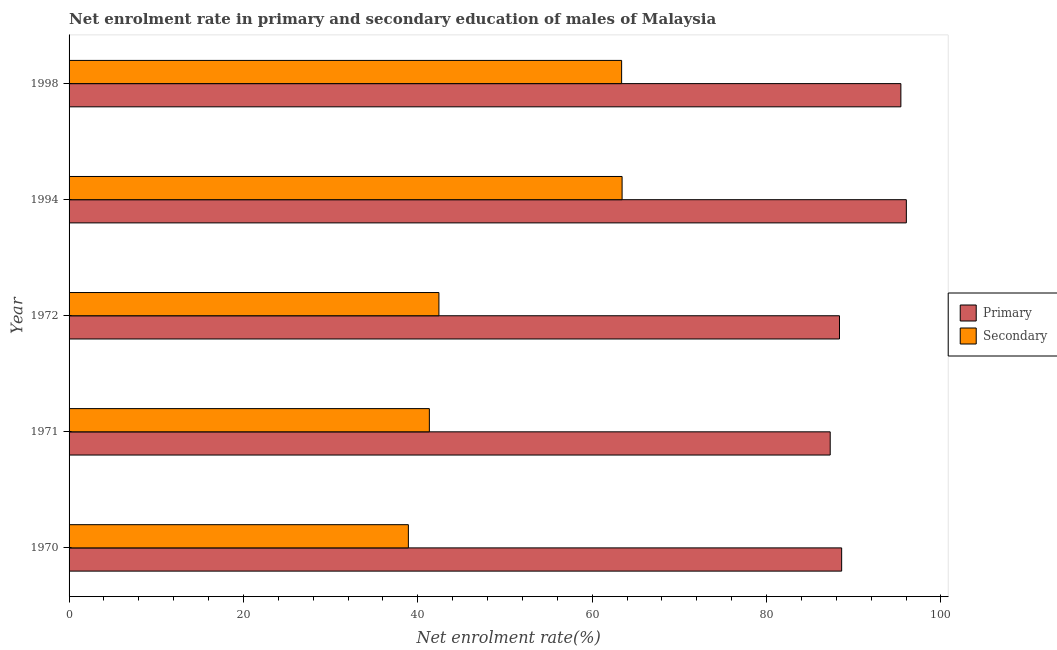Are the number of bars on each tick of the Y-axis equal?
Provide a short and direct response. Yes. What is the label of the 3rd group of bars from the top?
Provide a short and direct response. 1972. What is the enrollment rate in primary education in 1971?
Provide a succinct answer. 87.3. Across all years, what is the maximum enrollment rate in secondary education?
Offer a very short reply. 63.43. Across all years, what is the minimum enrollment rate in secondary education?
Give a very brief answer. 38.92. In which year was the enrollment rate in secondary education maximum?
Keep it short and to the point. 1994. In which year was the enrollment rate in secondary education minimum?
Offer a terse response. 1970. What is the total enrollment rate in secondary education in the graph?
Offer a terse response. 249.46. What is the difference between the enrollment rate in secondary education in 1970 and that in 1971?
Offer a very short reply. -2.41. What is the difference between the enrollment rate in primary education in 1998 and the enrollment rate in secondary education in 1972?
Your answer should be very brief. 52.98. What is the average enrollment rate in primary education per year?
Offer a terse response. 91.14. In the year 1998, what is the difference between the enrollment rate in primary education and enrollment rate in secondary education?
Keep it short and to the point. 32.03. In how many years, is the enrollment rate in primary education greater than 92 %?
Provide a short and direct response. 2. Is the difference between the enrollment rate in primary education in 1972 and 1994 greater than the difference between the enrollment rate in secondary education in 1972 and 1994?
Offer a terse response. Yes. What is the difference between the highest and the second highest enrollment rate in secondary education?
Ensure brevity in your answer.  0.05. What is the difference between the highest and the lowest enrollment rate in secondary education?
Ensure brevity in your answer.  24.51. In how many years, is the enrollment rate in secondary education greater than the average enrollment rate in secondary education taken over all years?
Keep it short and to the point. 2. What does the 2nd bar from the top in 1972 represents?
Offer a terse response. Primary. What does the 1st bar from the bottom in 1994 represents?
Offer a very short reply. Primary. Are all the bars in the graph horizontal?
Offer a terse response. Yes. How many years are there in the graph?
Offer a terse response. 5. Are the values on the major ticks of X-axis written in scientific E-notation?
Offer a very short reply. No. Does the graph contain any zero values?
Offer a very short reply. No. How many legend labels are there?
Make the answer very short. 2. How are the legend labels stacked?
Ensure brevity in your answer.  Vertical. What is the title of the graph?
Offer a very short reply. Net enrolment rate in primary and secondary education of males of Malaysia. What is the label or title of the X-axis?
Provide a succinct answer. Net enrolment rate(%). What is the label or title of the Y-axis?
Provide a short and direct response. Year. What is the Net enrolment rate(%) in Primary in 1970?
Keep it short and to the point. 88.61. What is the Net enrolment rate(%) in Secondary in 1970?
Offer a terse response. 38.92. What is the Net enrolment rate(%) in Primary in 1971?
Offer a terse response. 87.3. What is the Net enrolment rate(%) of Secondary in 1971?
Ensure brevity in your answer.  41.32. What is the Net enrolment rate(%) in Primary in 1972?
Keep it short and to the point. 88.36. What is the Net enrolment rate(%) in Secondary in 1972?
Ensure brevity in your answer.  42.42. What is the Net enrolment rate(%) in Primary in 1994?
Provide a short and direct response. 96.03. What is the Net enrolment rate(%) in Secondary in 1994?
Offer a very short reply. 63.43. What is the Net enrolment rate(%) of Primary in 1998?
Make the answer very short. 95.4. What is the Net enrolment rate(%) of Secondary in 1998?
Your response must be concise. 63.38. Across all years, what is the maximum Net enrolment rate(%) of Primary?
Offer a terse response. 96.03. Across all years, what is the maximum Net enrolment rate(%) in Secondary?
Keep it short and to the point. 63.43. Across all years, what is the minimum Net enrolment rate(%) in Primary?
Offer a very short reply. 87.3. Across all years, what is the minimum Net enrolment rate(%) of Secondary?
Make the answer very short. 38.92. What is the total Net enrolment rate(%) of Primary in the graph?
Keep it short and to the point. 455.71. What is the total Net enrolment rate(%) of Secondary in the graph?
Your response must be concise. 249.46. What is the difference between the Net enrolment rate(%) of Primary in 1970 and that in 1971?
Give a very brief answer. 1.31. What is the difference between the Net enrolment rate(%) in Secondary in 1970 and that in 1971?
Offer a terse response. -2.41. What is the difference between the Net enrolment rate(%) of Primary in 1970 and that in 1972?
Offer a very short reply. 0.25. What is the difference between the Net enrolment rate(%) of Secondary in 1970 and that in 1972?
Your answer should be compact. -3.5. What is the difference between the Net enrolment rate(%) in Primary in 1970 and that in 1994?
Offer a very short reply. -7.42. What is the difference between the Net enrolment rate(%) in Secondary in 1970 and that in 1994?
Provide a succinct answer. -24.51. What is the difference between the Net enrolment rate(%) in Primary in 1970 and that in 1998?
Ensure brevity in your answer.  -6.79. What is the difference between the Net enrolment rate(%) of Secondary in 1970 and that in 1998?
Your answer should be compact. -24.46. What is the difference between the Net enrolment rate(%) of Primary in 1971 and that in 1972?
Ensure brevity in your answer.  -1.06. What is the difference between the Net enrolment rate(%) of Secondary in 1971 and that in 1972?
Keep it short and to the point. -1.1. What is the difference between the Net enrolment rate(%) in Primary in 1971 and that in 1994?
Your answer should be compact. -8.73. What is the difference between the Net enrolment rate(%) of Secondary in 1971 and that in 1994?
Give a very brief answer. -22.11. What is the difference between the Net enrolment rate(%) in Primary in 1971 and that in 1998?
Ensure brevity in your answer.  -8.1. What is the difference between the Net enrolment rate(%) in Secondary in 1971 and that in 1998?
Give a very brief answer. -22.05. What is the difference between the Net enrolment rate(%) of Primary in 1972 and that in 1994?
Offer a very short reply. -7.67. What is the difference between the Net enrolment rate(%) of Secondary in 1972 and that in 1994?
Keep it short and to the point. -21.01. What is the difference between the Net enrolment rate(%) of Primary in 1972 and that in 1998?
Offer a very short reply. -7.04. What is the difference between the Net enrolment rate(%) in Secondary in 1972 and that in 1998?
Your answer should be very brief. -20.96. What is the difference between the Net enrolment rate(%) of Primary in 1994 and that in 1998?
Offer a terse response. 0.63. What is the difference between the Net enrolment rate(%) in Secondary in 1994 and that in 1998?
Keep it short and to the point. 0.05. What is the difference between the Net enrolment rate(%) of Primary in 1970 and the Net enrolment rate(%) of Secondary in 1971?
Your answer should be very brief. 47.29. What is the difference between the Net enrolment rate(%) of Primary in 1970 and the Net enrolment rate(%) of Secondary in 1972?
Make the answer very short. 46.19. What is the difference between the Net enrolment rate(%) in Primary in 1970 and the Net enrolment rate(%) in Secondary in 1994?
Make the answer very short. 25.18. What is the difference between the Net enrolment rate(%) of Primary in 1970 and the Net enrolment rate(%) of Secondary in 1998?
Provide a succinct answer. 25.24. What is the difference between the Net enrolment rate(%) in Primary in 1971 and the Net enrolment rate(%) in Secondary in 1972?
Make the answer very short. 44.88. What is the difference between the Net enrolment rate(%) in Primary in 1971 and the Net enrolment rate(%) in Secondary in 1994?
Your response must be concise. 23.87. What is the difference between the Net enrolment rate(%) of Primary in 1971 and the Net enrolment rate(%) of Secondary in 1998?
Keep it short and to the point. 23.92. What is the difference between the Net enrolment rate(%) of Primary in 1972 and the Net enrolment rate(%) of Secondary in 1994?
Keep it short and to the point. 24.93. What is the difference between the Net enrolment rate(%) of Primary in 1972 and the Net enrolment rate(%) of Secondary in 1998?
Your answer should be compact. 24.99. What is the difference between the Net enrolment rate(%) of Primary in 1994 and the Net enrolment rate(%) of Secondary in 1998?
Your response must be concise. 32.66. What is the average Net enrolment rate(%) in Primary per year?
Ensure brevity in your answer.  91.14. What is the average Net enrolment rate(%) of Secondary per year?
Offer a very short reply. 49.89. In the year 1970, what is the difference between the Net enrolment rate(%) in Primary and Net enrolment rate(%) in Secondary?
Make the answer very short. 49.7. In the year 1971, what is the difference between the Net enrolment rate(%) of Primary and Net enrolment rate(%) of Secondary?
Ensure brevity in your answer.  45.98. In the year 1972, what is the difference between the Net enrolment rate(%) of Primary and Net enrolment rate(%) of Secondary?
Provide a short and direct response. 45.94. In the year 1994, what is the difference between the Net enrolment rate(%) of Primary and Net enrolment rate(%) of Secondary?
Provide a short and direct response. 32.6. In the year 1998, what is the difference between the Net enrolment rate(%) of Primary and Net enrolment rate(%) of Secondary?
Your answer should be compact. 32.03. What is the ratio of the Net enrolment rate(%) of Secondary in 1970 to that in 1971?
Make the answer very short. 0.94. What is the ratio of the Net enrolment rate(%) of Primary in 1970 to that in 1972?
Your answer should be compact. 1. What is the ratio of the Net enrolment rate(%) in Secondary in 1970 to that in 1972?
Your answer should be very brief. 0.92. What is the ratio of the Net enrolment rate(%) in Primary in 1970 to that in 1994?
Your answer should be compact. 0.92. What is the ratio of the Net enrolment rate(%) of Secondary in 1970 to that in 1994?
Provide a short and direct response. 0.61. What is the ratio of the Net enrolment rate(%) of Primary in 1970 to that in 1998?
Offer a very short reply. 0.93. What is the ratio of the Net enrolment rate(%) in Secondary in 1970 to that in 1998?
Offer a very short reply. 0.61. What is the ratio of the Net enrolment rate(%) of Secondary in 1971 to that in 1972?
Offer a terse response. 0.97. What is the ratio of the Net enrolment rate(%) in Primary in 1971 to that in 1994?
Your answer should be compact. 0.91. What is the ratio of the Net enrolment rate(%) in Secondary in 1971 to that in 1994?
Offer a terse response. 0.65. What is the ratio of the Net enrolment rate(%) of Primary in 1971 to that in 1998?
Your answer should be compact. 0.92. What is the ratio of the Net enrolment rate(%) of Secondary in 1971 to that in 1998?
Your answer should be compact. 0.65. What is the ratio of the Net enrolment rate(%) of Primary in 1972 to that in 1994?
Make the answer very short. 0.92. What is the ratio of the Net enrolment rate(%) of Secondary in 1972 to that in 1994?
Ensure brevity in your answer.  0.67. What is the ratio of the Net enrolment rate(%) in Primary in 1972 to that in 1998?
Your response must be concise. 0.93. What is the ratio of the Net enrolment rate(%) of Secondary in 1972 to that in 1998?
Make the answer very short. 0.67. What is the ratio of the Net enrolment rate(%) in Primary in 1994 to that in 1998?
Your answer should be very brief. 1.01. What is the ratio of the Net enrolment rate(%) of Secondary in 1994 to that in 1998?
Provide a succinct answer. 1. What is the difference between the highest and the second highest Net enrolment rate(%) of Primary?
Offer a very short reply. 0.63. What is the difference between the highest and the second highest Net enrolment rate(%) in Secondary?
Provide a succinct answer. 0.05. What is the difference between the highest and the lowest Net enrolment rate(%) in Primary?
Offer a terse response. 8.73. What is the difference between the highest and the lowest Net enrolment rate(%) of Secondary?
Offer a very short reply. 24.51. 